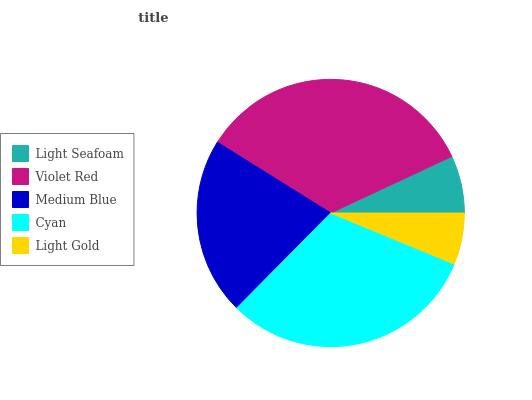Is Light Gold the minimum?
Answer yes or no. Yes. Is Violet Red the maximum?
Answer yes or no. Yes. Is Medium Blue the minimum?
Answer yes or no. No. Is Medium Blue the maximum?
Answer yes or no. No. Is Violet Red greater than Medium Blue?
Answer yes or no. Yes. Is Medium Blue less than Violet Red?
Answer yes or no. Yes. Is Medium Blue greater than Violet Red?
Answer yes or no. No. Is Violet Red less than Medium Blue?
Answer yes or no. No. Is Medium Blue the high median?
Answer yes or no. Yes. Is Medium Blue the low median?
Answer yes or no. Yes. Is Violet Red the high median?
Answer yes or no. No. Is Violet Red the low median?
Answer yes or no. No. 